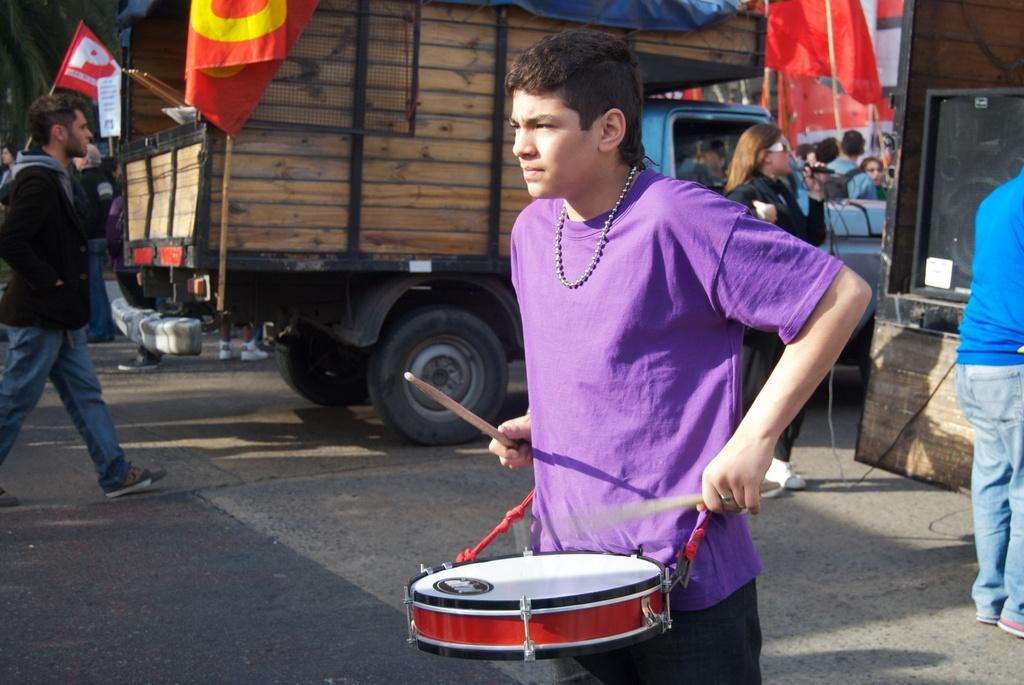What is the main subject of the image? The main subject of the image is a man. What is the man wearing in the image? The man is wearing a purple t-shirt in the image. What is the man doing in the image? The man is playing a musical instrument in the image. What can be seen in the background of the image? There are people, vehicles, and flags visible in the background of the image. What word is written on the man's t-shirt in the image? There is no word written on the man's t-shirt in the image; it is simply described as purple. How many digits are visible on the man's hand in the image? There are no visible digits or numbers on the man's hand in the image. 